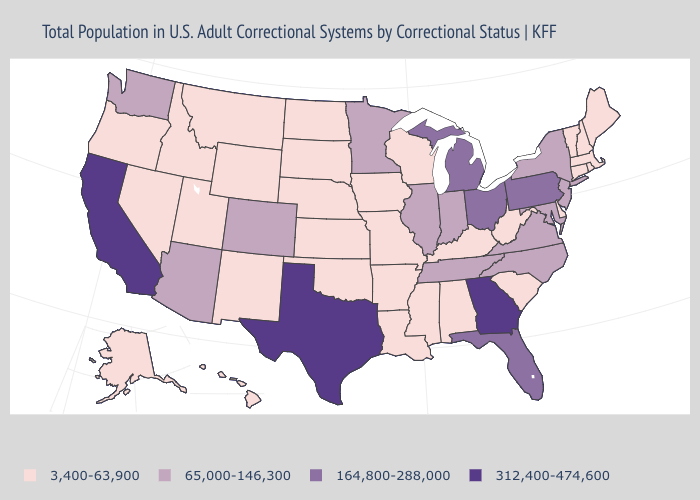Among the states that border Montana , which have the highest value?
Short answer required. Idaho, North Dakota, South Dakota, Wyoming. Name the states that have a value in the range 164,800-288,000?
Quick response, please. Florida, Michigan, Ohio, Pennsylvania. Does California have the highest value in the USA?
Quick response, please. Yes. Which states have the lowest value in the USA?
Answer briefly. Alabama, Alaska, Arkansas, Connecticut, Delaware, Hawaii, Idaho, Iowa, Kansas, Kentucky, Louisiana, Maine, Massachusetts, Mississippi, Missouri, Montana, Nebraska, Nevada, New Hampshire, New Mexico, North Dakota, Oklahoma, Oregon, Rhode Island, South Carolina, South Dakota, Utah, Vermont, West Virginia, Wisconsin, Wyoming. Among the states that border Ohio , which have the highest value?
Keep it brief. Michigan, Pennsylvania. What is the value of South Dakota?
Be succinct. 3,400-63,900. What is the value of Kansas?
Give a very brief answer. 3,400-63,900. Does Florida have a higher value than Georgia?
Be succinct. No. What is the highest value in states that border Mississippi?
Short answer required. 65,000-146,300. What is the value of Minnesota?
Quick response, please. 65,000-146,300. Is the legend a continuous bar?
Write a very short answer. No. What is the value of Idaho?
Quick response, please. 3,400-63,900. Among the states that border Idaho , which have the highest value?
Write a very short answer. Washington. What is the value of North Dakota?
Concise answer only. 3,400-63,900. What is the lowest value in the West?
Concise answer only. 3,400-63,900. 